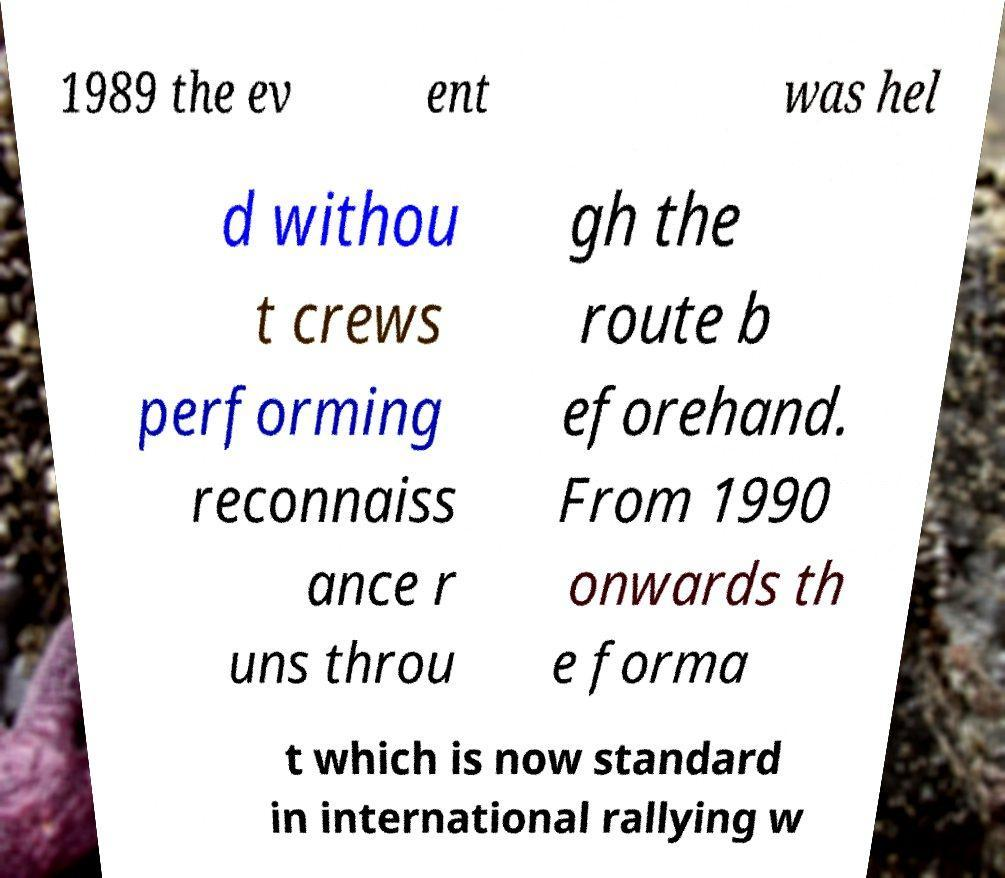What messages or text are displayed in this image? I need them in a readable, typed format. 1989 the ev ent was hel d withou t crews performing reconnaiss ance r uns throu gh the route b eforehand. From 1990 onwards th e forma t which is now standard in international rallying w 